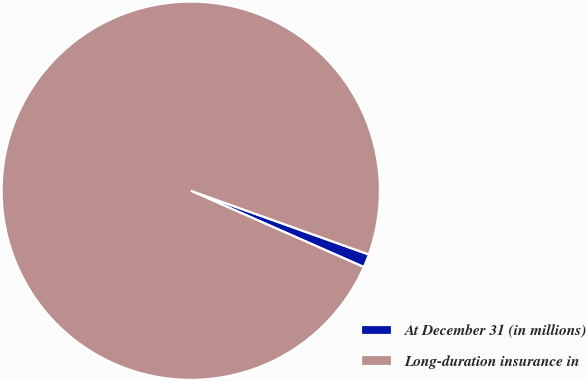Convert chart. <chart><loc_0><loc_0><loc_500><loc_500><pie_chart><fcel>At December 31 (in millions)<fcel>Long-duration insurance in<nl><fcel>1.14%<fcel>98.86%<nl></chart> 